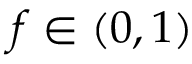Convert formula to latex. <formula><loc_0><loc_0><loc_500><loc_500>f \in ( 0 , 1 )</formula> 